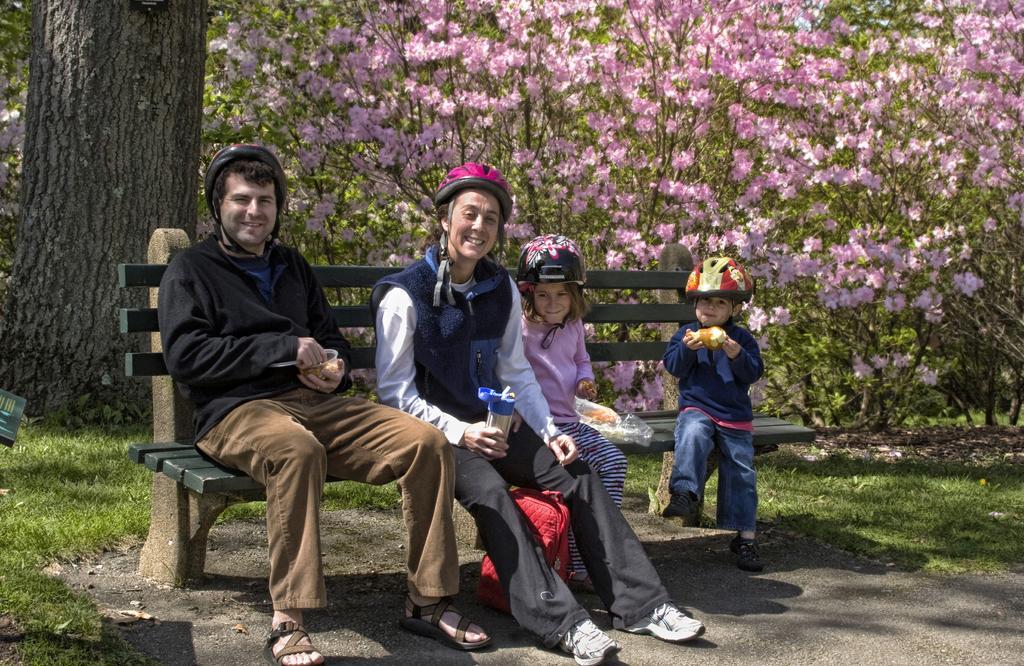Could you give a brief overview of what you see in this image? In this image, there are four persons sitting on the bench and all are wearing helmet on their head. In the left side of the image, there is a tree trunk. In the background of the image, flowering trees are visible which are having pink color flowers. In the bottom of the image, the grass is surrounded on the both side. The picture is taken in a sunny day. 